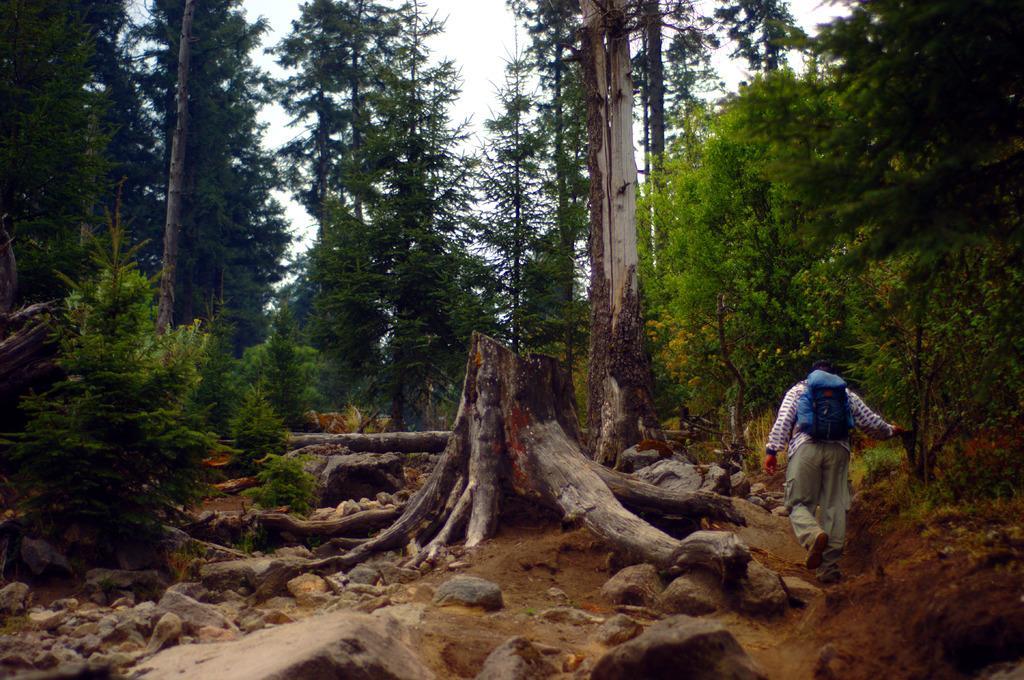Can you describe this image briefly? In the image we can see a person wearing clothes, shoes and the person is hanging a bag on his back. There is a tree trunk, stones, plant, trees and a sky. 